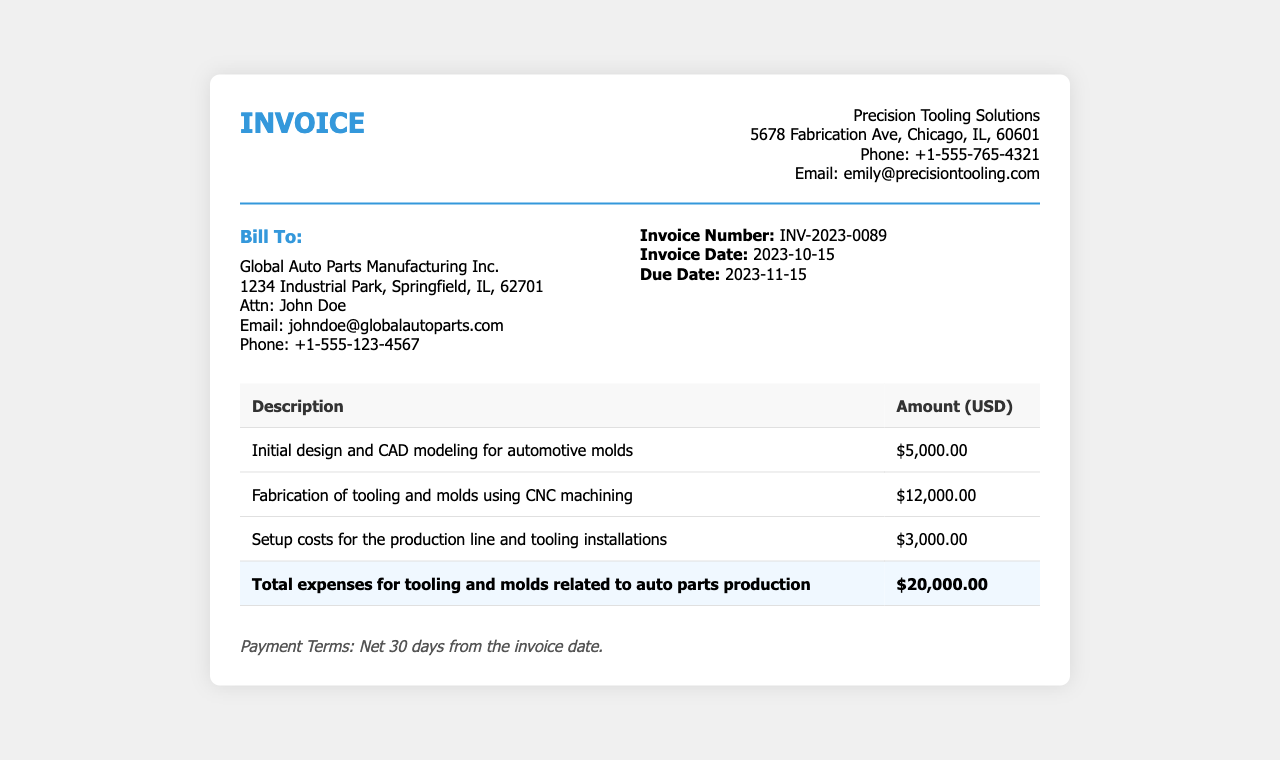What is the invoice number? The invoice number is specified in the document under supplier info, which is a unique identifier for this invoice.
Answer: INV-2023-0089 What is the invoice date? The invoice date is provided in the supplier info section, indicating when the invoice was issued.
Answer: 2023-10-15 What is the due date for payment? The due date is mentioned in the supplier info and is when the payment is expected to be made.
Answer: 2023-11-15 What is the total amount due for this invoice? The total amount is calculated by summing all listed expenses in the table.
Answer: $20,000.00 How much was charged for the fabrication of tooling and molds? The charge for this service is listed in the table under the specific description of the service.
Answer: $12,000.00 Who is the billing address for this invoice? The billing address consists of the company details to which the invoice is sent, found in the billing info section.
Answer: Global Auto Parts Manufacturing Inc., 1234 Industrial Park, Springfield, IL, 62701 What does the payment terms state? The payment terms specify how long the payer has to settle the invoice after the invoice date.
Answer: Net 30 days from the invoice date What service is associated with the amount of $5,000.00? This amount corresponds to a specific line item in the expense table related to design services.
Answer: Initial design and CAD modeling for automotive molds 